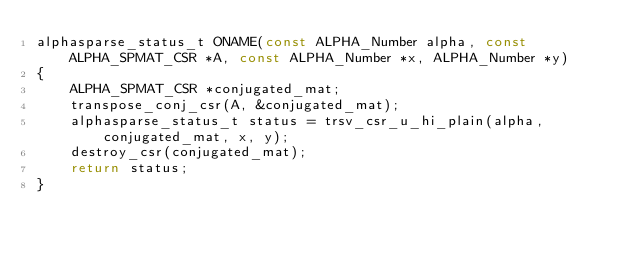<code> <loc_0><loc_0><loc_500><loc_500><_C_>alphasparse_status_t ONAME(const ALPHA_Number alpha, const ALPHA_SPMAT_CSR *A, const ALPHA_Number *x, ALPHA_Number *y)
{
    ALPHA_SPMAT_CSR *conjugated_mat;
    transpose_conj_csr(A, &conjugated_mat);
    alphasparse_status_t status = trsv_csr_u_hi_plain(alpha, conjugated_mat, x, y);
    destroy_csr(conjugated_mat);
    return status;
}
</code> 